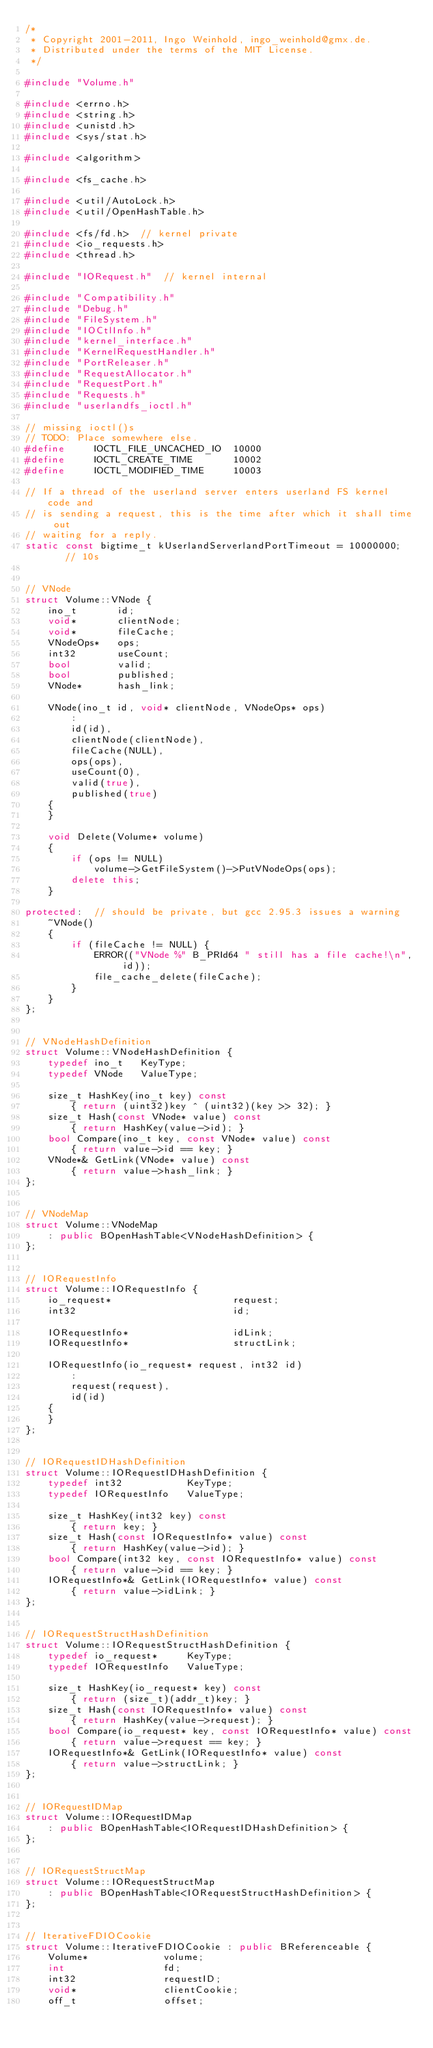Convert code to text. <code><loc_0><loc_0><loc_500><loc_500><_C++_>/*
 * Copyright 2001-2011, Ingo Weinhold, ingo_weinhold@gmx.de.
 * Distributed under the terms of the MIT License.
 */

#include "Volume.h"

#include <errno.h>
#include <string.h>
#include <unistd.h>
#include <sys/stat.h>

#include <algorithm>

#include <fs_cache.h>

#include <util/AutoLock.h>
#include <util/OpenHashTable.h>

#include <fs/fd.h>	// kernel private
#include <io_requests.h>
#include <thread.h>

#include "IORequest.h"	// kernel internal

#include "Compatibility.h"
#include "Debug.h"
#include "FileSystem.h"
#include "IOCtlInfo.h"
#include "kernel_interface.h"
#include "KernelRequestHandler.h"
#include "PortReleaser.h"
#include "RequestAllocator.h"
#include "RequestPort.h"
#include "Requests.h"
#include "userlandfs_ioctl.h"

// missing ioctl()s
// TODO: Place somewhere else.
#define		IOCTL_FILE_UNCACHED_IO	10000
#define		IOCTL_CREATE_TIME		10002
#define		IOCTL_MODIFIED_TIME		10003

// If a thread of the userland server enters userland FS kernel code and
// is sending a request, this is the time after which it shall time out
// waiting for a reply.
static const bigtime_t kUserlandServerlandPortTimeout = 10000000;	// 10s


// VNode
struct Volume::VNode {
	ino_t		id;
	void*		clientNode;
	void*		fileCache;
	VNodeOps*	ops;
	int32		useCount;
	bool		valid;
	bool		published;
	VNode*		hash_link;

	VNode(ino_t id, void* clientNode, VNodeOps* ops)
		:
		id(id),
		clientNode(clientNode),
		fileCache(NULL),
		ops(ops),
		useCount(0),
		valid(true),
		published(true)
	{
	}

	void Delete(Volume* volume)
	{
		if (ops != NULL)
			volume->GetFileSystem()->PutVNodeOps(ops);
		delete this;
	}

protected:	// should be private, but gcc 2.95.3 issues a warning
	~VNode()
	{
		if (fileCache != NULL) {
			ERROR(("VNode %" B_PRId64 " still has a file cache!\n", id));
			file_cache_delete(fileCache);
		}
	}
};


// VNodeHashDefinition
struct Volume::VNodeHashDefinition {
	typedef ino_t	KeyType;
	typedef	VNode	ValueType;

	size_t HashKey(ino_t key) const
		{ return (uint32)key ^ (uint32)(key >> 32); }
	size_t Hash(const VNode* value) const
		{ return HashKey(value->id); }
	bool Compare(ino_t key, const VNode* value) const
		{ return value->id == key; }
	VNode*& GetLink(VNode* value) const
		{ return value->hash_link; }
};


// VNodeMap
struct Volume::VNodeMap
	: public BOpenHashTable<VNodeHashDefinition> {
};


// IORequestInfo
struct Volume::IORequestInfo {
	io_request*						request;
	int32							id;

	IORequestInfo*					idLink;
	IORequestInfo*					structLink;

	IORequestInfo(io_request* request, int32 id)
		:
		request(request),
		id(id)
	{
	}
};


// IORequestIDHashDefinition
struct Volume::IORequestIDHashDefinition {
	typedef int32			KeyType;
	typedef	IORequestInfo	ValueType;

	size_t HashKey(int32 key) const
		{ return key; }
	size_t Hash(const IORequestInfo* value) const
		{ return HashKey(value->id); }
	bool Compare(int32 key, const IORequestInfo* value) const
		{ return value->id == key; }
	IORequestInfo*& GetLink(IORequestInfo* value) const
		{ return value->idLink; }
};


// IORequestStructHashDefinition
struct Volume::IORequestStructHashDefinition {
	typedef io_request*		KeyType;
	typedef	IORequestInfo	ValueType;

	size_t HashKey(io_request* key) const
		{ return (size_t)(addr_t)key; }
	size_t Hash(const IORequestInfo* value) const
		{ return HashKey(value->request); }
	bool Compare(io_request* key, const IORequestInfo* value) const
		{ return value->request == key; }
	IORequestInfo*& GetLink(IORequestInfo* value) const
		{ return value->structLink; }
};


// IORequestIDMap
struct Volume::IORequestIDMap
	: public BOpenHashTable<IORequestIDHashDefinition> {
};


// IORequestStructMap
struct Volume::IORequestStructMap
	: public BOpenHashTable<IORequestStructHashDefinition> {
};


// IterativeFDIOCookie
struct Volume::IterativeFDIOCookie : public BReferenceable {
	Volume*				volume;
	int					fd;
	int32				requestID;
	void*				clientCookie;
	off_t				offset;</code> 